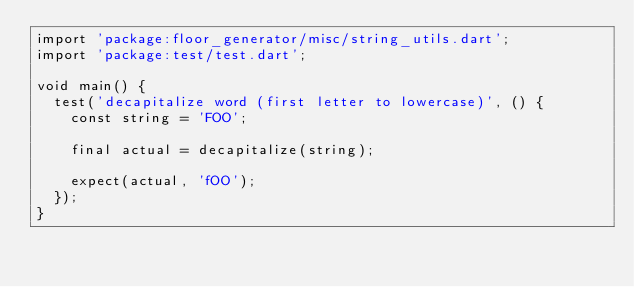Convert code to text. <code><loc_0><loc_0><loc_500><loc_500><_Dart_>import 'package:floor_generator/misc/string_utils.dart';
import 'package:test/test.dart';

void main() {
  test('decapitalize word (first letter to lowercase)', () {
    const string = 'FOO';

    final actual = decapitalize(string);

    expect(actual, 'fOO');
  });
}
</code> 